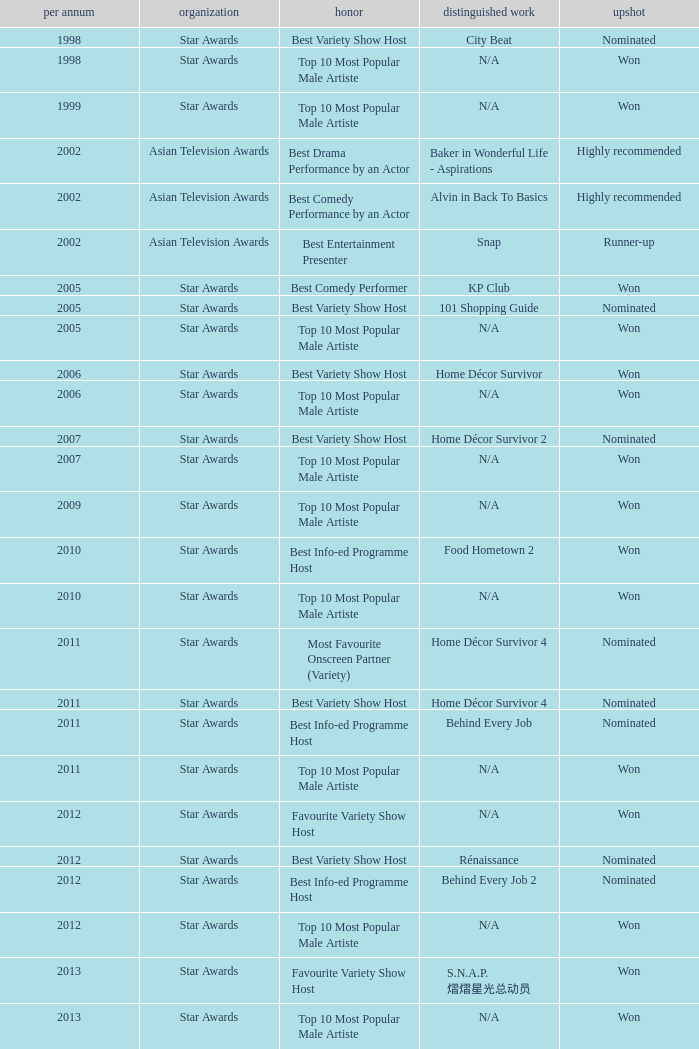What is the award for the Star Awards earlier than 2005 and the result is won? Top 10 Most Popular Male Artiste, Top 10 Most Popular Male Artiste. 